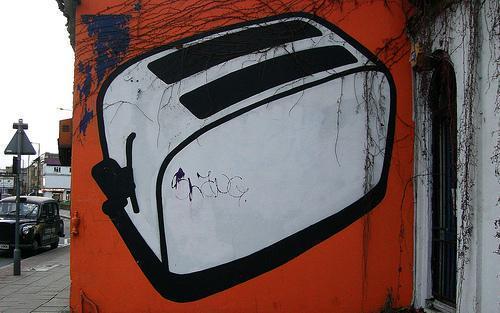How many toasters are there?
Give a very brief answer. 1. 